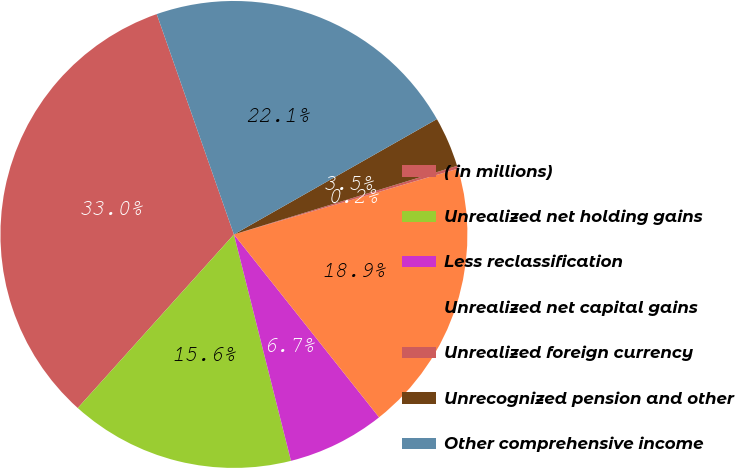Convert chart to OTSL. <chart><loc_0><loc_0><loc_500><loc_500><pie_chart><fcel>( in millions)<fcel>Unrealized net holding gains<fcel>Less reclassification<fcel>Unrealized net capital gains<fcel>Unrealized foreign currency<fcel>Unrecognized pension and other<fcel>Other comprehensive income<nl><fcel>32.98%<fcel>15.59%<fcel>6.75%<fcel>18.87%<fcel>0.2%<fcel>3.48%<fcel>22.14%<nl></chart> 